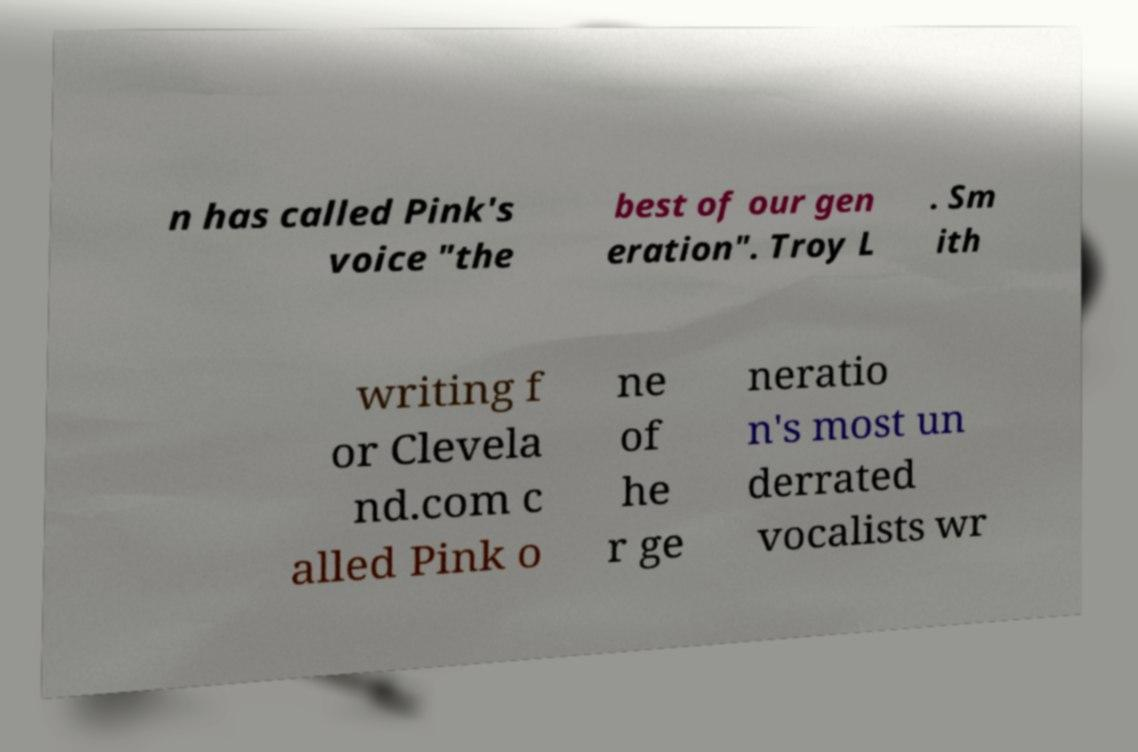Could you assist in decoding the text presented in this image and type it out clearly? n has called Pink's voice "the best of our gen eration". Troy L . Sm ith writing f or Clevela nd.com c alled Pink o ne of he r ge neratio n's most un derrated vocalists wr 